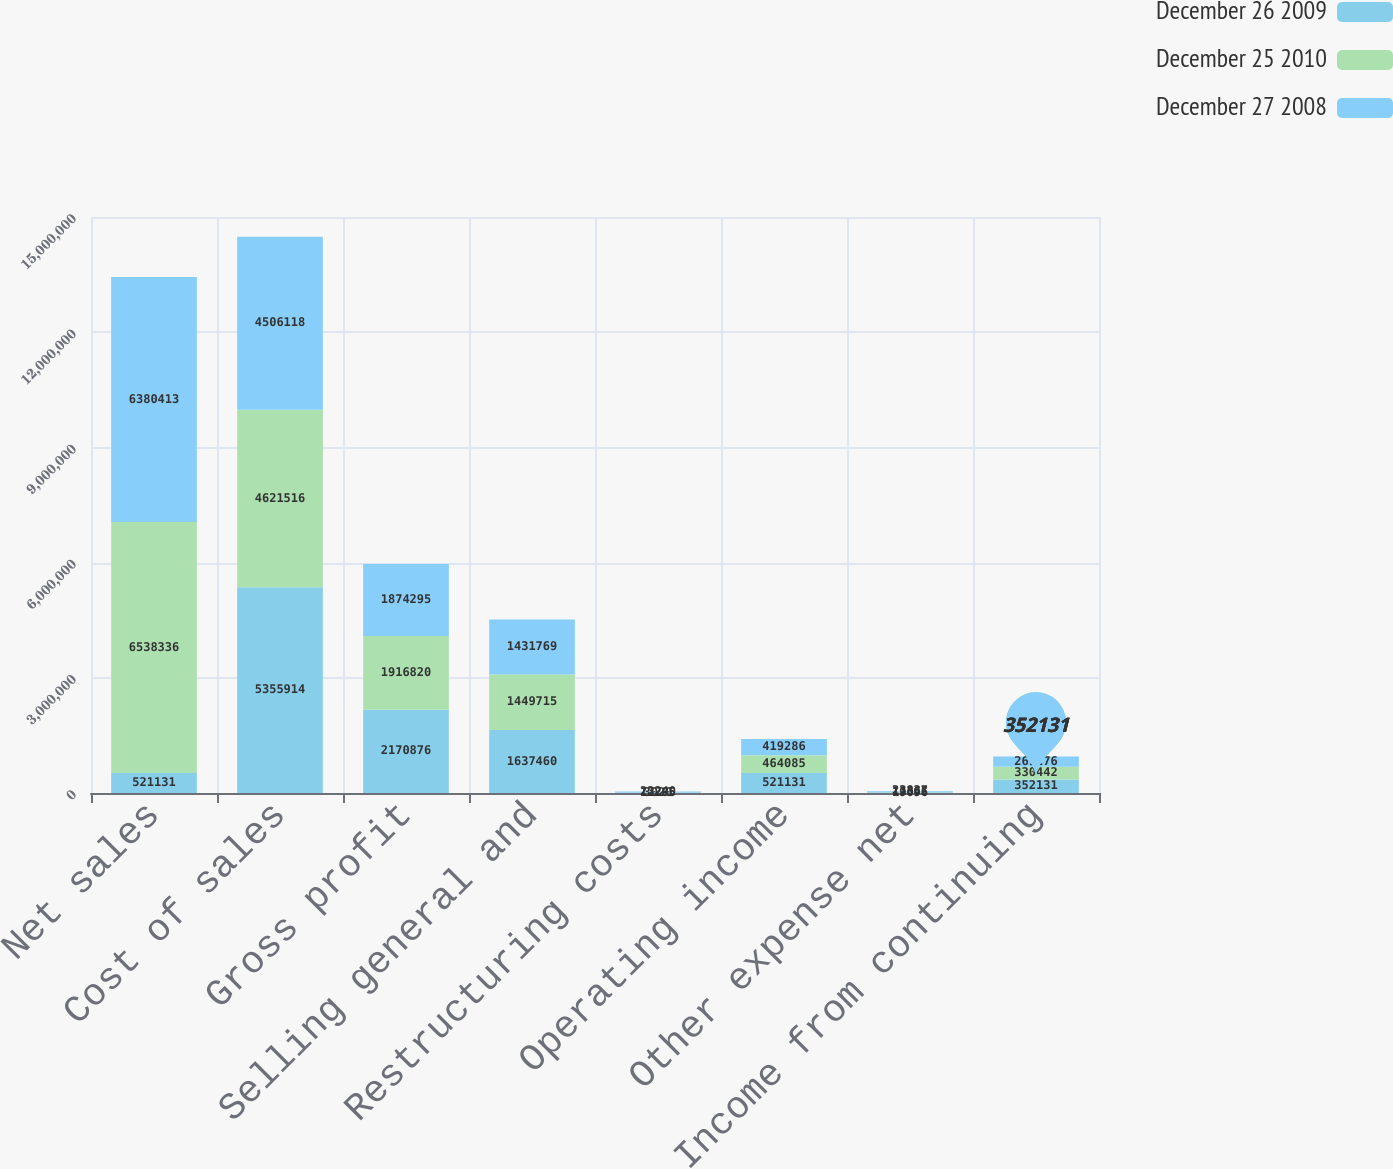Convert chart to OTSL. <chart><loc_0><loc_0><loc_500><loc_500><stacked_bar_chart><ecel><fcel>Net sales<fcel>Cost of sales<fcel>Gross profit<fcel>Selling general and<fcel>Restructuring costs<fcel>Operating income<fcel>Other expense net<fcel>Income from continuing<nl><fcel>December 26 2009<fcel>521131<fcel>5.35591e+06<fcel>2.17088e+06<fcel>1.63746e+06<fcel>12285<fcel>521131<fcel>19096<fcel>352131<nl><fcel>December 25 2010<fcel>6.53834e+06<fcel>4.62152e+06<fcel>1.91682e+06<fcel>1.44972e+06<fcel>3020<fcel>464085<fcel>11365<fcel>330442<nl><fcel>December 27 2008<fcel>6.38041e+06<fcel>4.50612e+06<fcel>1.8743e+06<fcel>1.43177e+06<fcel>23240<fcel>419286<fcel>23837<fcel>269276<nl></chart> 